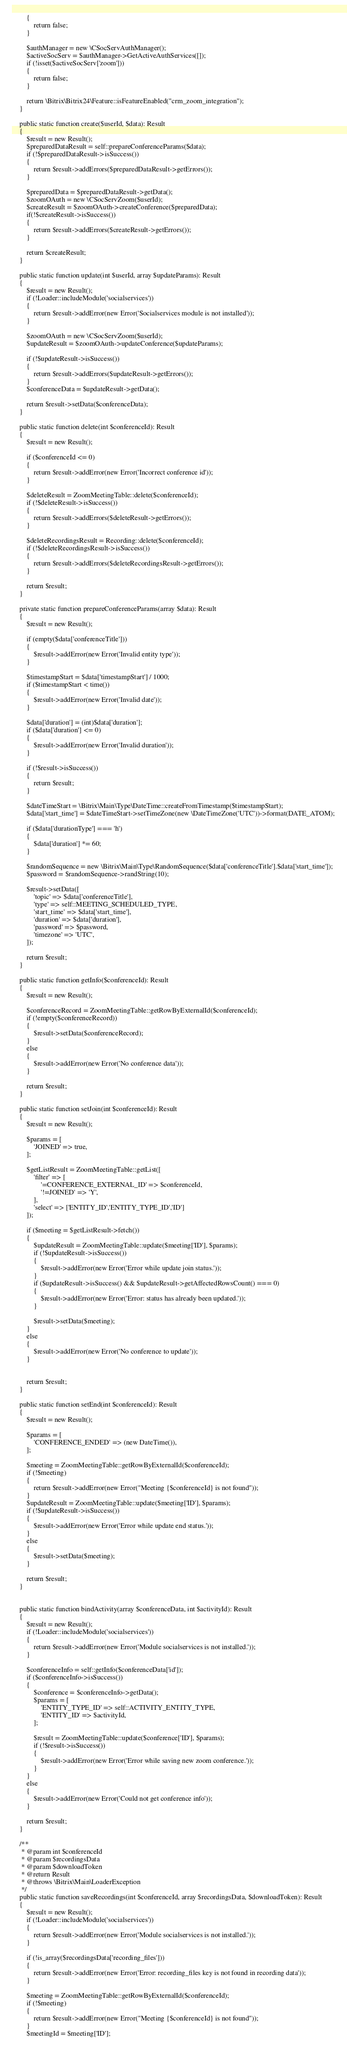<code> <loc_0><loc_0><loc_500><loc_500><_PHP_>		{
			return false;
		}

		$authManager = new \CSocServAuthManager();
		$activeSocServ = $authManager->GetActiveAuthServices([]);
		if (!isset($activeSocServ['zoom']))
		{
			return false;
		}

		return \Bitrix\Bitrix24\Feature::isFeatureEnabled("crm_zoom_integration");
	}

	public static function create($userId, $data): Result
	{
		$result = new Result();
		$preparedDataResult = self::prepareConferenceParams($data);
		if (!$preparedDataResult->isSuccess())
		{
			return $result->addErrors($preparedDataResult->getErrors());
		}

		$preparedData = $preparedDataResult->getData();
		$zoomOAuth = new \CSocServZoom($userId);
		$createResult = $zoomOAuth->createConference($preparedData);
		if(!$createResult->isSuccess())
		{
			return $result->addErrors($createResult->getErrors());
		}

		return $createResult;
	}

	public static function update(int $userId, array $updateParams): Result
	{
		$result = new Result();
		if (!Loader::includeModule('socialservices'))
		{
			return $result->addError(new Error('Socialservices module is not installed'));
		}

		$zoomOAuth = new \CSocServZoom($userId);
		$updateResult = $zoomOAuth->updateConference($updateParams);

		if (!$updateResult->isSuccess())
		{
			return $result->addErrors($updateResult->getErrors());
		}
		$conferenceData = $updateResult->getData();

		return $result->setData($conferenceData);
	}

	public static function delete(int $conferenceId): Result
	{
		$result = new Result();

		if ($conferenceId <= 0)
		{
			return $result->addError(new Error('Incorrect conference id'));
		}

		$deleteResult = ZoomMeetingTable::delete($conferenceId);
		if (!$deleteResult->isSuccess())
		{
			return $result->addErrors($deleteResult->getErrors());
		}

		$deleteRecordingsResult = Recording::delete($conferenceId);
		if (!$deleteRecordingsResult->isSuccess())
		{
			return $result->addErrors($deleteRecordingsResult->getErrors());
		}

		return $result;
	}

	private static function prepareConferenceParams(array $data): Result
	{
		$result = new Result();

		if (empty($data['conferenceTitle']))
		{
			$result->addError(new Error('Invalid entity type'));
		}

		$timestampStart = $data['timestampStart'] / 1000;
		if ($timestampStart < time())
		{
			$result->addError(new Error('Invalid date'));
		}

		$data['duration'] = (int)$data['duration'];
		if ($data['duration'] <= 0)
		{
			$result->addError(new Error('Invalid duration'));
		}

		if (!$result->isSuccess())
		{
			return $result;
		}

		$dateTimeStart = \Bitrix\Main\Type\DateTime::createFromTimestamp($timestampStart);
		$data['start_time'] = $dateTimeStart->setTimeZone(new \DateTimeZone('UTC'))->format(DATE_ATOM);

		if ($data['durationType'] === 'h')
		{
			$data['duration'] *= 60;
		}

		$randomSequence = new \Bitrix\Main\Type\RandomSequence($data['conferenceTitle'].$data['start_time']);
		$password = $randomSequence->randString(10);

		$result->setData([
			'topic' => $data['conferenceTitle'],
			'type' => self::MEETING_SCHEDULED_TYPE,
			'start_time' => $data['start_time'],
			'duration' => $data['duration'],
			'password' => $password,
			'timezone' => 'UTC',
		]);

		return $result;
	}

	public static function getInfo($conferenceId): Result
	{
		$result = new Result();

		$conferenceRecord = ZoomMeetingTable::getRowByExternalId($conferenceId);
		if (!empty($conferenceRecord))
		{
			$result->setData($conferenceRecord);
		}
		else
		{
			$result->addError(new Error('No conference data'));
		}

		return $result;
	}

	public static function setJoin(int $conferenceId): Result
	{
		$result = new Result();

		$params = [
			'JOINED' => true,
		];

		$getListResult = ZoomMeetingTable::getList([
			'filter' => [
				'=CONFERENCE_EXTERNAL_ID' => $conferenceId,
				'!=JOINED' => 'Y',
			],
			'select' => ['ENTITY_ID','ENTITY_TYPE_ID','ID']
		]);

		if ($meeting = $getListResult->fetch())
		{
			$updateResult = ZoomMeetingTable::update($meeting['ID'], $params);
			if (!$updateResult->isSuccess())
			{
				$result->addError(new Error('Error while update join status.'));
			}
			if ($updateResult->isSuccess() && $updateResult->getAffectedRowsCount() === 0)
			{
				$result->addError(new Error('Error: status has already been updated.'));
			}

			$result->setData($meeting);
		}
		else
		{
			$result->addError(new Error('No conference to update'));
		}


		return $result;
	}

	public static function setEnd(int $conferenceId): Result
	{
		$result = new Result();

		$params = [
			'CONFERENCE_ENDED' => (new DateTime()),
		];

		$meeting = ZoomMeetingTable::getRowByExternalId($conferenceId);
		if (!$meeting)
		{
			return $result->addError(new Error("Meeting {$conferenceId} is not found"));
		}
		$updateResult = ZoomMeetingTable::update($meeting['ID'], $params);
		if (!$updateResult->isSuccess())
		{
			$result->addError(new Error('Error while update end status.'));
		}
		else
		{
			$result->setData($meeting);
		}

		return $result;
	}


	public static function bindActivity(array $conferenceData, int $activityId): Result
	{
		$result = new Result();
		if (!Loader::includeModule('socialservices'))
		{
			return $result->addError(new Error('Module socialservices is not installed.'));
		}

		$conferenceInfo = self::getInfo($conferenceData['id']);
		if ($conferenceInfo->isSuccess())
		{
			$conference = $conferenceInfo->getData();
			$params = [
				'ENTITY_TYPE_ID' => self::ACTIVITY_ENTITY_TYPE,
				'ENTITY_ID' => $activityId,
			];

			$result = ZoomMeetingTable::update($conference['ID'], $params);
			if (!$result->isSuccess())
			{
				$result->addError(new Error('Error while saving new zoom conference.'));
			}
		}
		else
		{
			$result->addError(new Error('Could not get conference info'));
		}

		return $result;
	}

	/**
	 * @param int $conferenceId
	 * @param $recordingsData
	 * @param $downloadToken
	 * @return Result
	 * @throws \Bitrix\Main\LoaderException
	 */
	public static function saveRecordings(int $conferenceId, array $recordingsData, $downloadToken): Result
	{
		$result = new Result();
		if (!Loader::includeModule('socialservices'))
		{
			return $result->addError(new Error('Module socialservices is not installed.'));
		}

		if (!is_array($recordingsData['recording_files']))
		{
			return $result->addError(new Error('Error: recording_files key is not found in recording data'));
		}

		$meeting = ZoomMeetingTable::getRowByExternalId($conferenceId);
		if (!$meeting)
		{
			return $result->addError(new Error("Meeting {$conferenceId} is not found"));
		}
		$meetingId = $meeting['ID'];</code> 